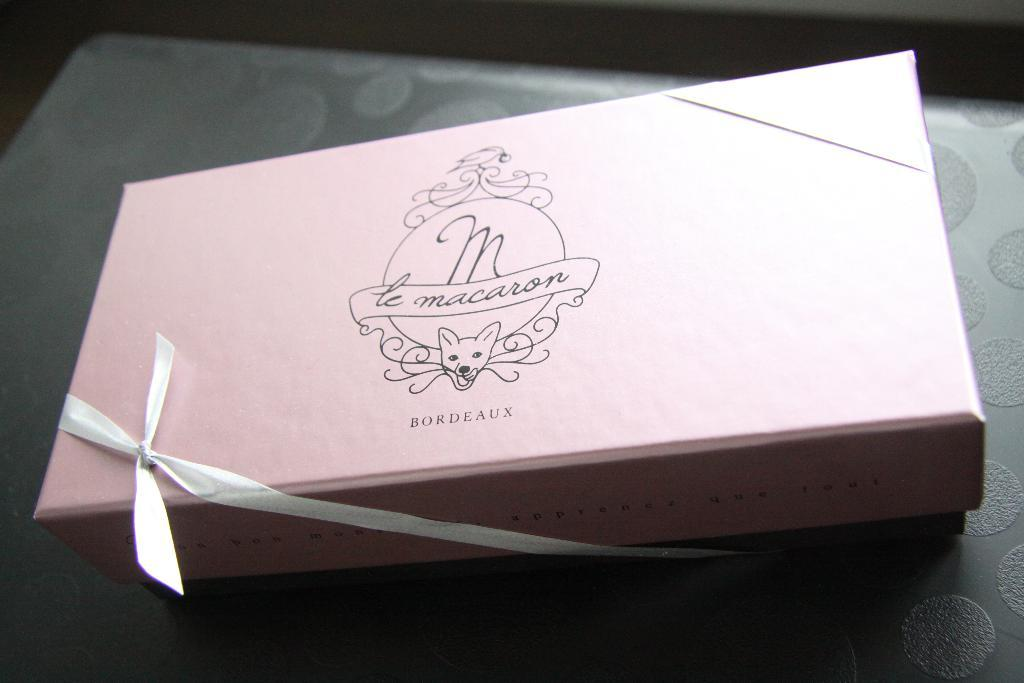<image>
Summarize the visual content of the image. A pink box which has the word Bordeaux on the bottom. 